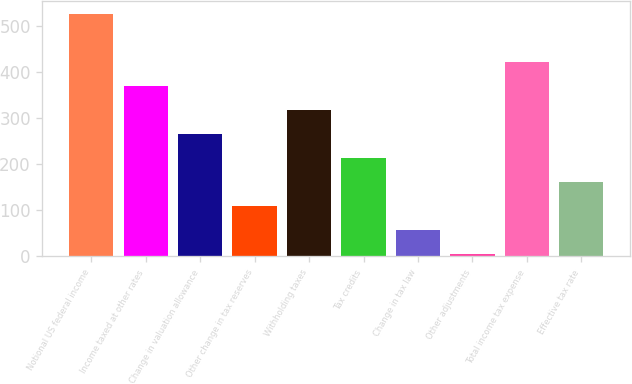Convert chart. <chart><loc_0><loc_0><loc_500><loc_500><bar_chart><fcel>Notional US federal income<fcel>Income taxed at other rates<fcel>Change in valuation allowance<fcel>Other change in tax reserves<fcel>Withholding taxes<fcel>Tax credits<fcel>Change in tax law<fcel>Other adjustments<fcel>Total income tax expense<fcel>Effective tax rate<nl><fcel>527<fcel>370.4<fcel>266<fcel>109.4<fcel>318.2<fcel>213.8<fcel>57.2<fcel>5<fcel>422.6<fcel>161.6<nl></chart> 